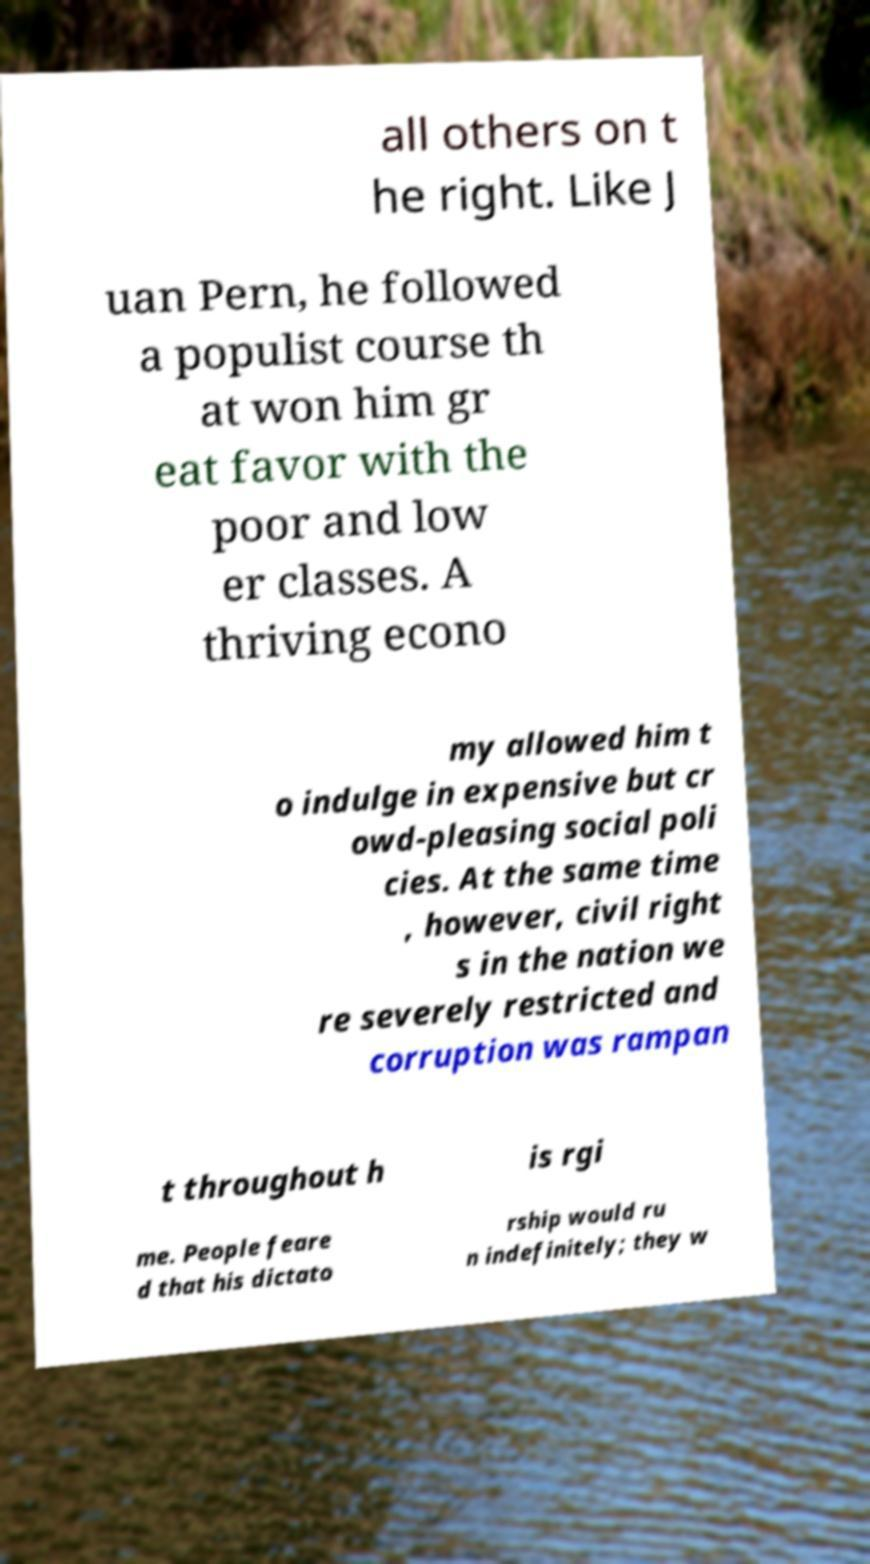There's text embedded in this image that I need extracted. Can you transcribe it verbatim? all others on t he right. Like J uan Pern, he followed a populist course th at won him gr eat favor with the poor and low er classes. A thriving econo my allowed him t o indulge in expensive but cr owd-pleasing social poli cies. At the same time , however, civil right s in the nation we re severely restricted and corruption was rampan t throughout h is rgi me. People feare d that his dictato rship would ru n indefinitely; they w 